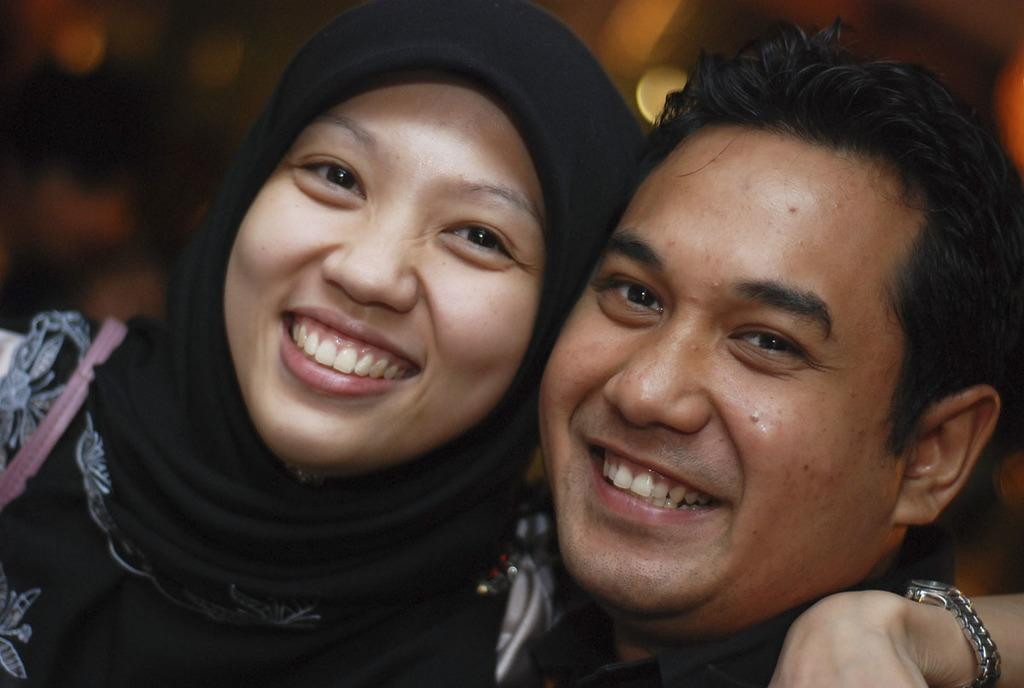Who is present in the image? There is a man and a woman in the image. What expressions do the man and woman have in the image? Both the man and woman are smiling in the image. Can you describe the background of the image? The background of the image appears blurry. What type of writing can be seen on the wall in the image? There is no writing visible on the wall in the image. Where is the cannon located in the image? There is no cannon present in the image. 